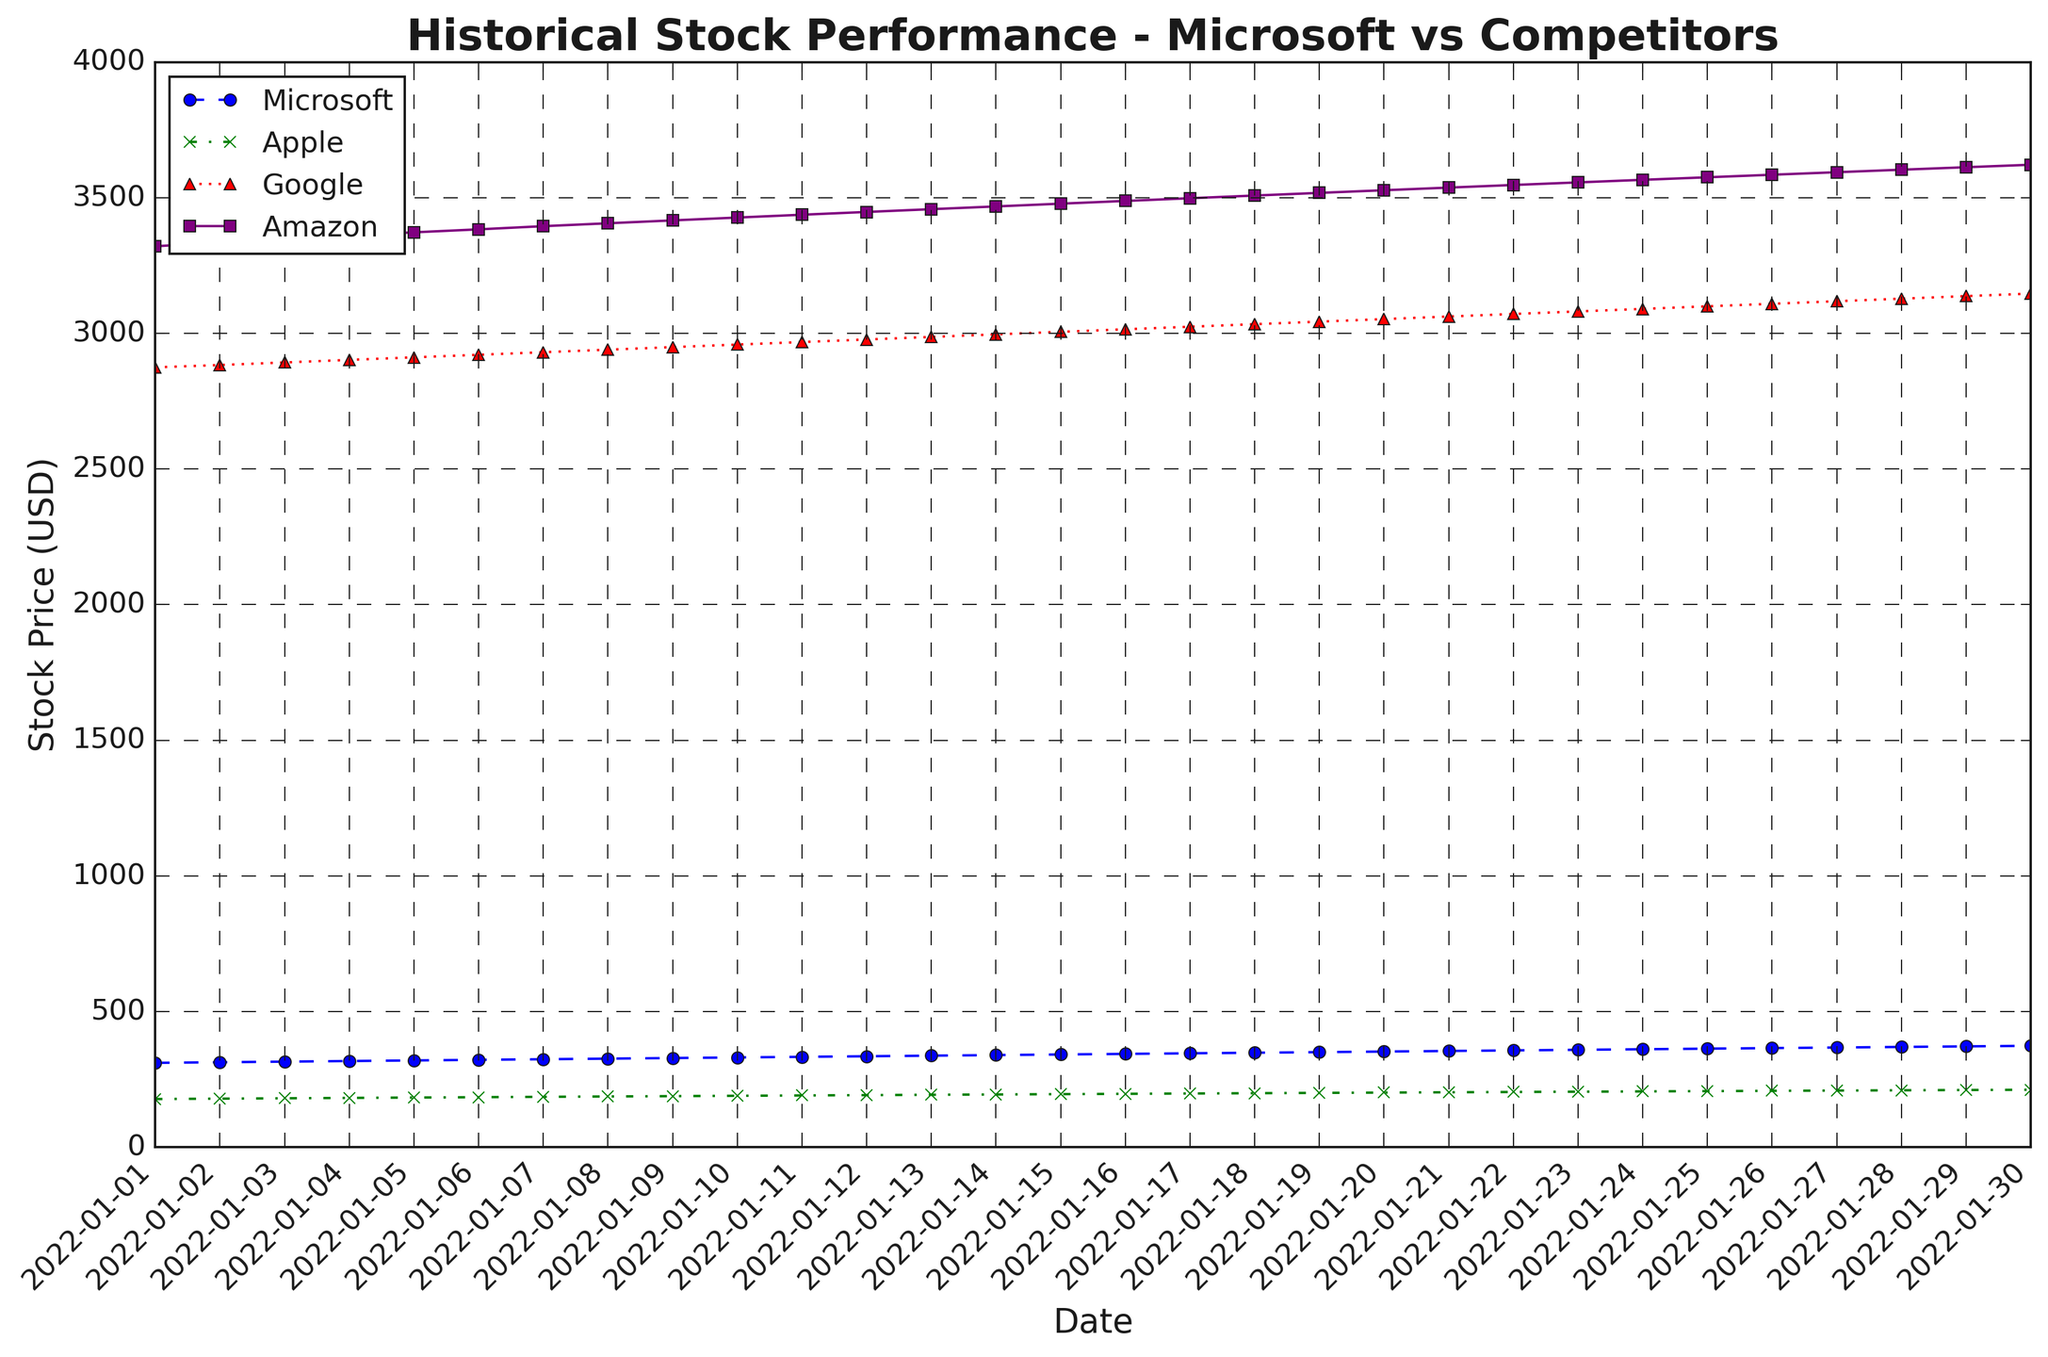What's the stock price of Microsoft on January 20, 2022? Locate the Date '2022-01-20' on the x-axis. Follow the blue dashed line with circle markers up to where it intersects the y-axis. The value at this intersection is the stock price of Microsoft.
Answer: 352.57 Which company's stock had the highest price on January 5, 2022? Look at the Date '2022-01-05' and examine the Y-axis values for each colored line. The highest value corresponds to Amazon, indicated by the purple solid line with square markers.
Answer: Amazon What's the average stock price of Google from January 1 to January 10, 2022? Sum the stock prices of Google for each day from January 1 to January 10 (2874.50 + 2883.10+ 2892.60 + 2902.10 + 2911.50 + 2920.90 + 2930.30 + 2939.70 + 2949.10 + 2958.50) and then divide by the number of days (10).
Answer: 2918.03 Which company shows the steepest upward trend in the stock price from January 1 to January 30, 2022? Compare the slopes of the lines for each company. The steepest slope indicates the highest price change over time. Microsoft shows the most significant increase, indicated by the blue dashed line.
Answer: Microsoft On which date did Apple's stock price exceed 200? Follow the green dash-dot line with cross markers and identify the first date where the y-axis value exceeds 200. This occurs on January 18, 2022.
Answer: January 18, 2022 What's the total increase in Amazon's stock price from January 1 to January 30, 2022? Subtract Amazon's price on January 1 (3320.68) from its price on January 30 (3621.32) to find the total increase.
Answer: 300.64 Compare the stock prices of Microsoft and Google on January 15, 2022. Which price is higher and by how much? Find the stock prices of Microsoft and Google on January 15. Microsoft is at 341.80 and Google is at 3005.50. Compare them and calculate the difference.
Answer: Microsoft; 263.70 What is the difference between the highest and lowest stock prices of Apple during the period shown? Identify the highest and lowest points on the green dash-dot line with cross markers. The highest price is 211.85 and the lowest is 177.57. Subtract the lowest from the highest.
Answer: 34.28 Identify the date when Google’s stock price reaches 3100 for the first time. Follow the red dotted line with triangle markers and identify the first date where it crosses the 3100 mark. This occurs on January 26, 2022.
Answer: January 26, 2022 Which company's stock price showed the least fluctuation between January 1 and January 30, 2022? Compare the range of stock prices (highest - lowest) for each company. Apple, indicated by the green dash-dot line with cross markers, shows the least fluctuation.
Answer: Apple 